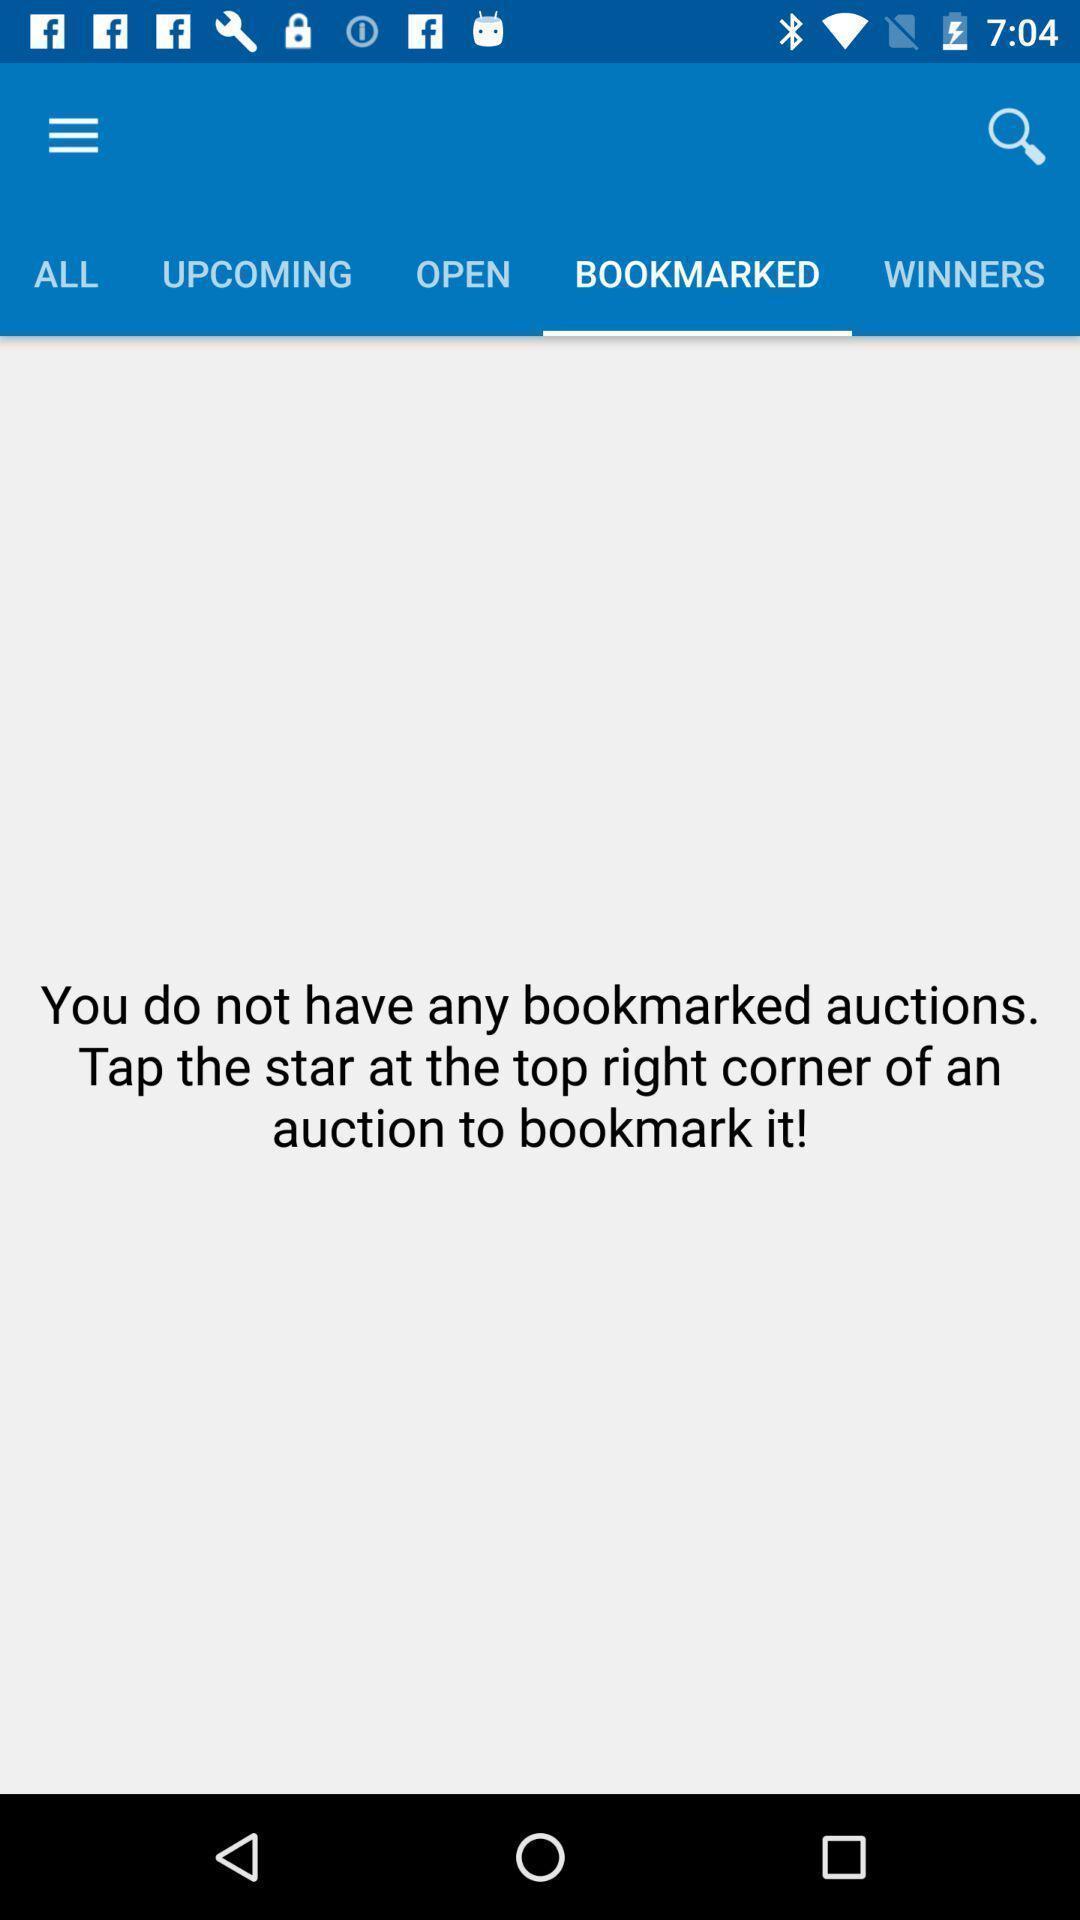Describe the visual elements of this screenshot. Window displaying about bookmark page. 